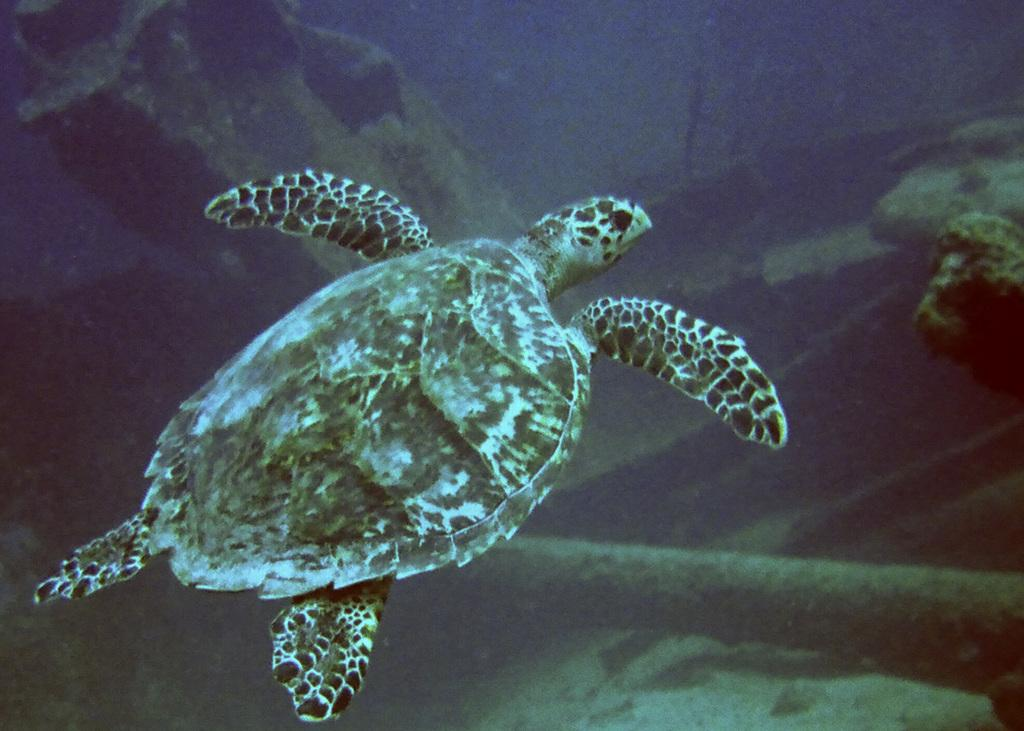What animal is in the water in the image? There is a tortoise in the water in the image. What can be seen in the background of the image? There are stones visible in the background of the image, as well as a few other objects. Is the tortoise driving a car in the image? No, the tortoise is not driving a car in the image; it is in the water. 